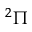<formula> <loc_0><loc_0><loc_500><loc_500>^ { 2 } \Pi</formula> 